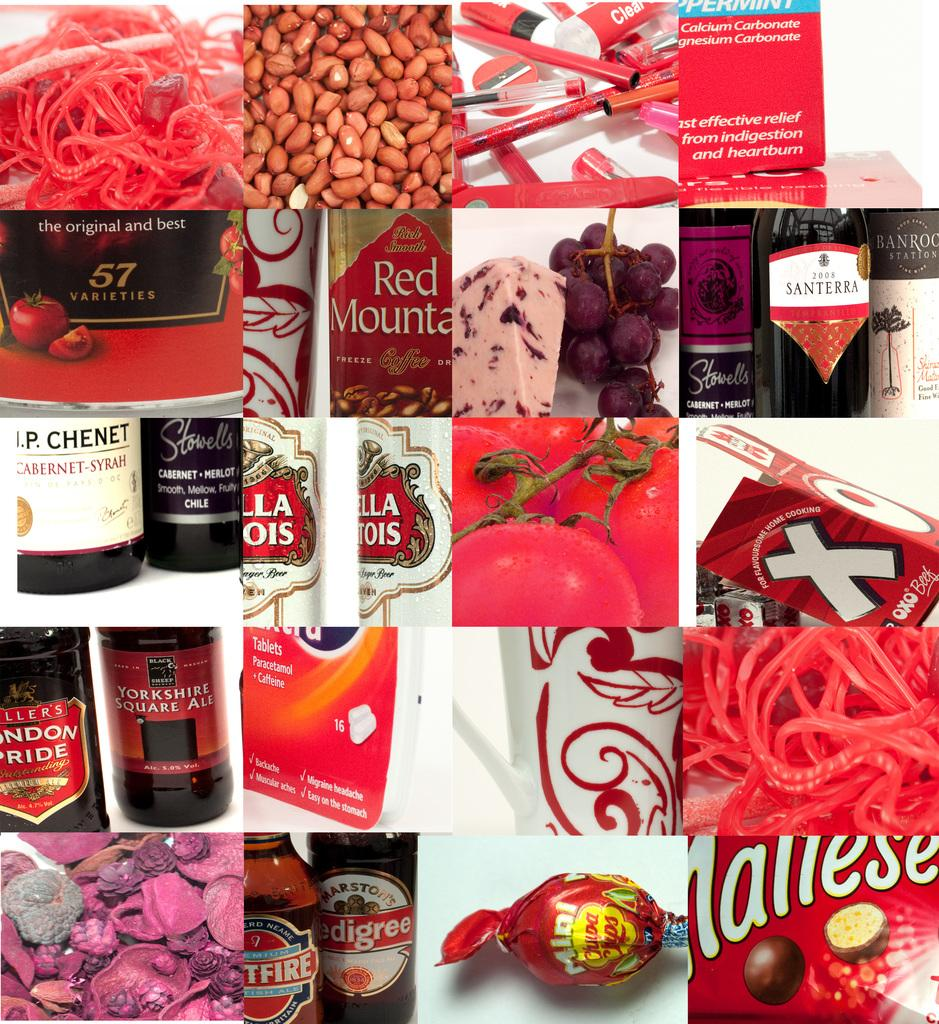<image>
Write a terse but informative summary of the picture. A collection of joined pictures depicts numerous products, like Red Mountain and Stella Artois. 